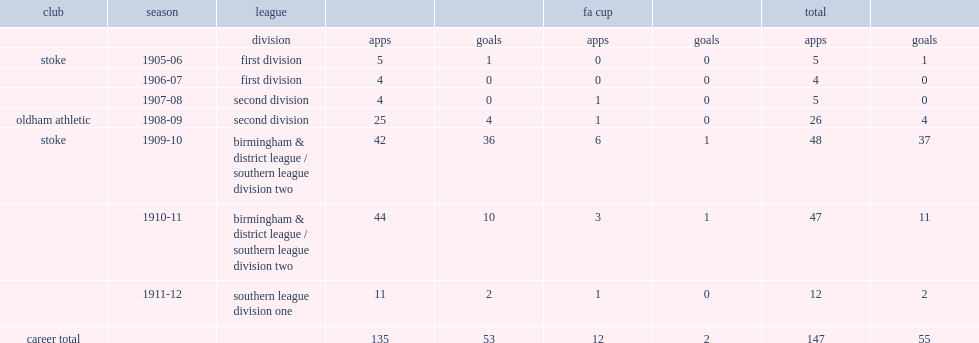Which league did griffiths join for oldham athletic? Second division. 